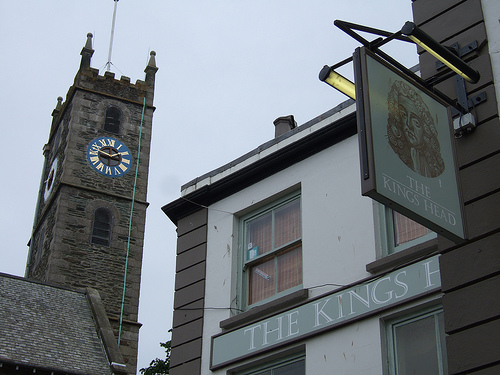What might be the historical significance of the clock tower? The clock tower likely holds significant historical value, potentially serving as a central landmark in the town for many generations. Such towers were often integral to community life, housing bells that marked time and events or signaling important announcements. The architecture suggests it may date back several centuries, witnessing the town's evolution over time. 